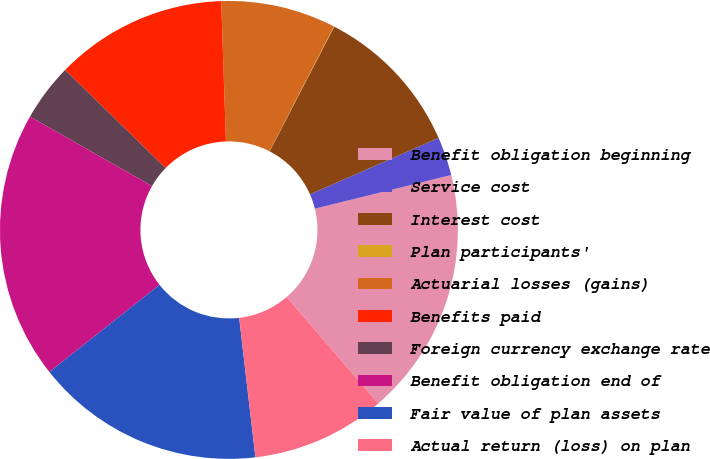<chart> <loc_0><loc_0><loc_500><loc_500><pie_chart><fcel>Benefit obligation beginning<fcel>Service cost<fcel>Interest cost<fcel>Plan participants'<fcel>Actuarial losses (gains)<fcel>Benefits paid<fcel>Foreign currency exchange rate<fcel>Benefit obligation end of<fcel>Fair value of plan assets<fcel>Actual return (loss) on plan<nl><fcel>17.54%<fcel>2.73%<fcel>10.81%<fcel>0.03%<fcel>8.11%<fcel>12.15%<fcel>4.07%<fcel>18.89%<fcel>16.19%<fcel>9.46%<nl></chart> 